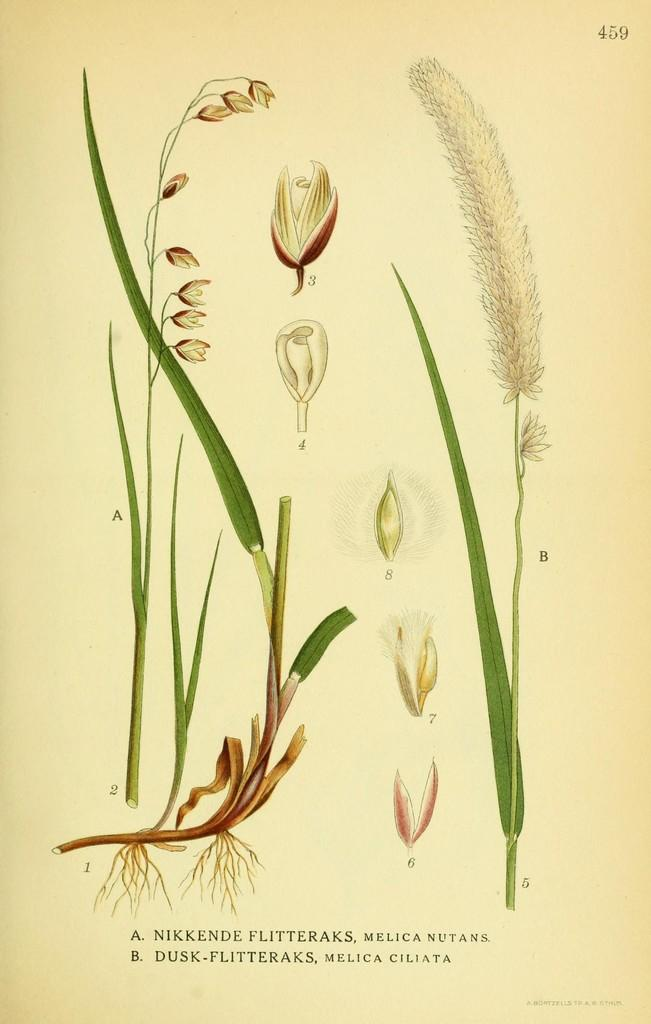What type of living organisms are depicted in the image or text? The image or text contains a picture of plants. What are the main parts of the plants that can be seen? The plants have leaves, flowers, stems, and roots. Are there any unopened flowers in the image or text? Yes, there are flower buds in the image or text. Is there any text or writing present in the image or text? Yes, there are letters in the paper. What type of guide can be seen in the image or text? There is no guide present in the image or text; it contains a picture of plants and letters. Is there a mine visible in the image or text? There is no mine present in the image or text; it contains a picture of plants and letters. 